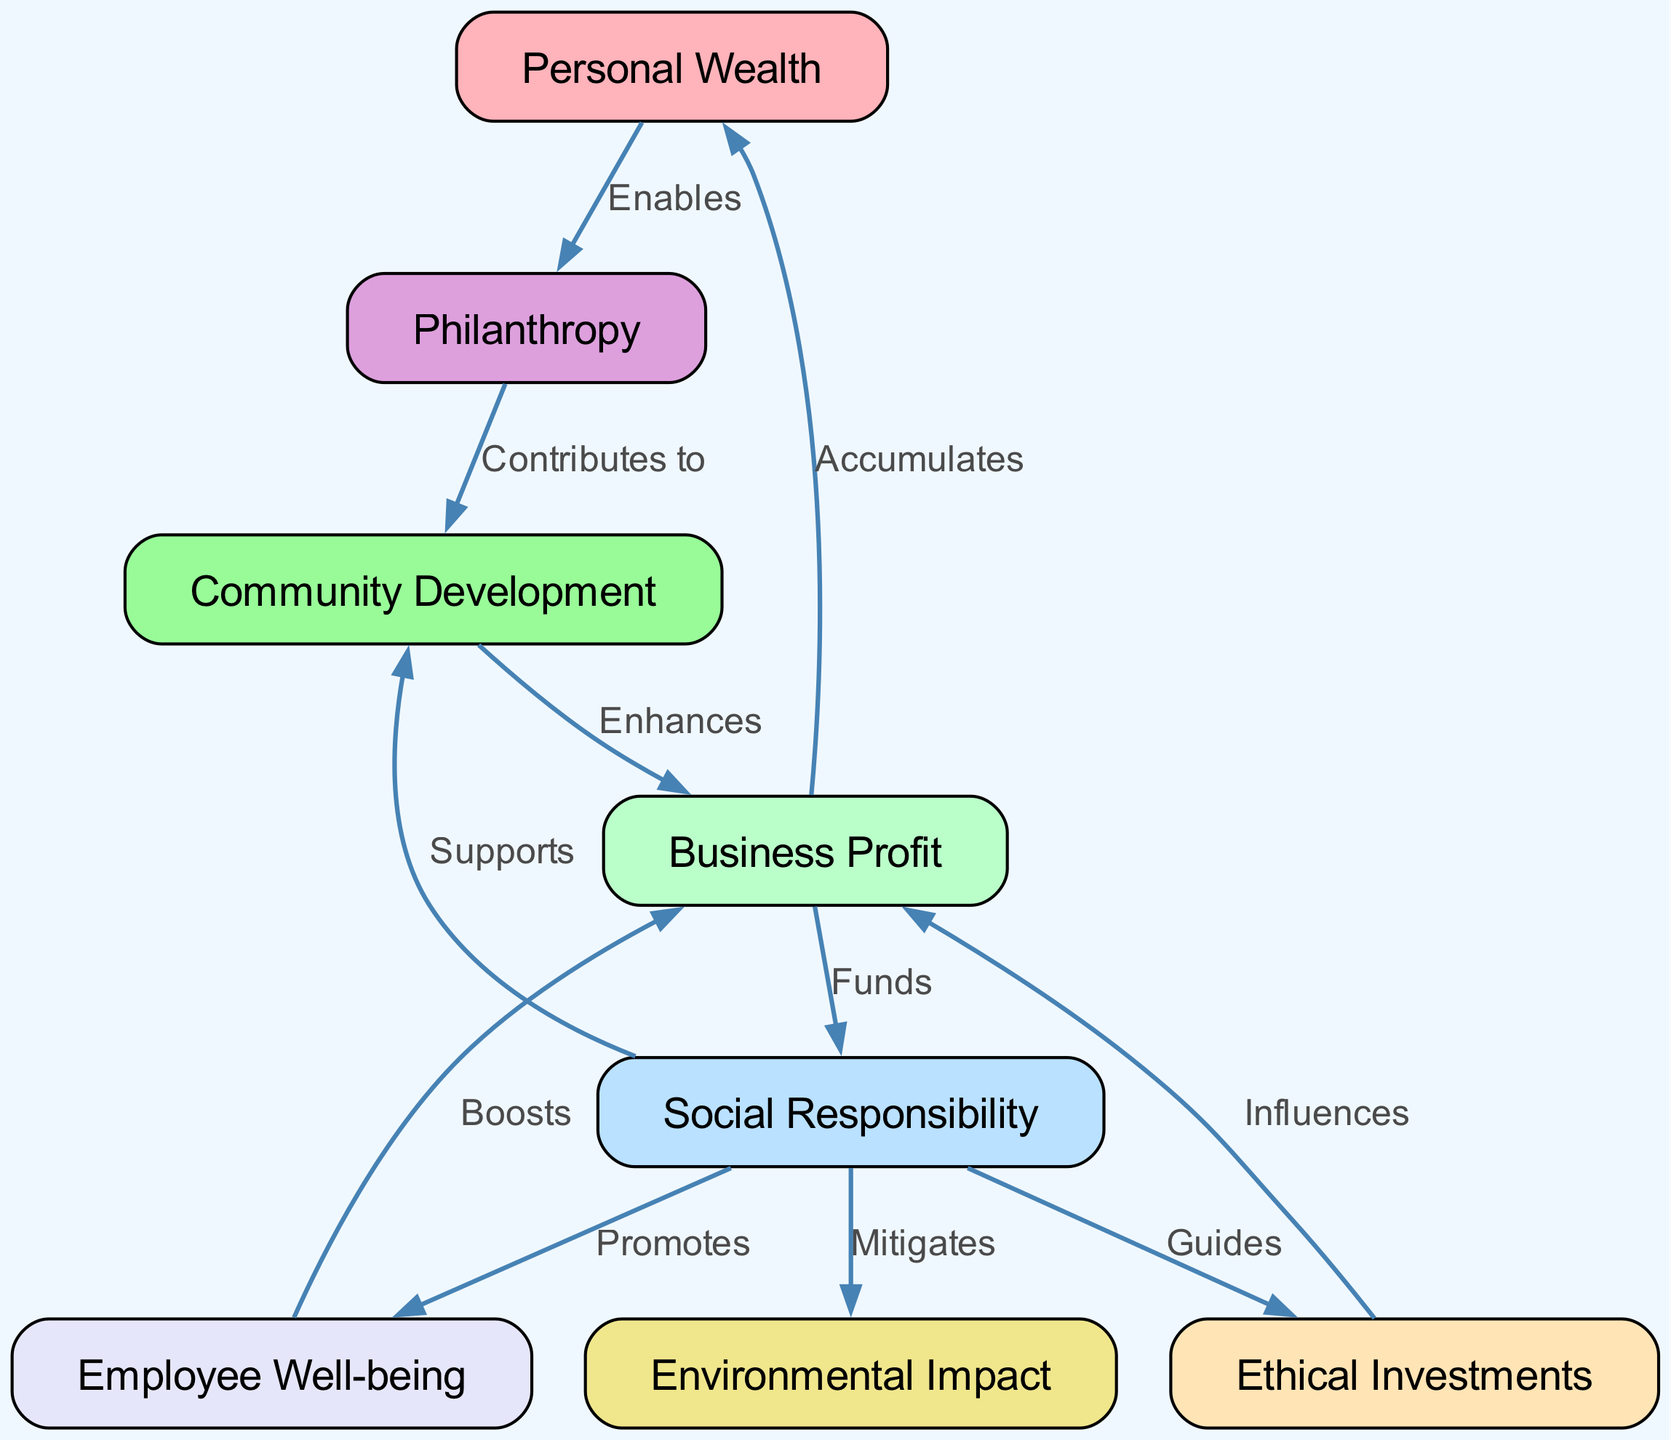What are the total number of nodes in the diagram? The diagram contains 8 distinct nodes as indicated in the data provided under "nodes." Each unique entity in the network, such as "Personal Wealth," "Business Profit," and others, counts as a separate node.
Answer: 8 What is the relation between "Business Profit" and "Personal Wealth"? The edge labeled "Accumulates" connects "Business Profit" to "Personal Wealth," indicating that business profit contributes to an increase in personal wealth. This is clearly stated in the edge's label within the diagram.
Answer: Accumulates How many edges are there in the diagram? By counting the entries listed under "edges," we find there are 10 relationships that connect the nodes. Each entry represents a directed connection from one node to another, showing their interactions.
Answer: 10 What does "Social Responsibility" promote? The diagram shows that "Social Responsibility" has an influence on "Employee Well-being," indicated by an edge labeled "Promotes." It highlights the role of social responsibility in enhancing employee experience.
Answer: Employee Well-being Which node directly supports "Community Development"? "Social Responsibility" directly connects to "Community Development" via the edge labeled "Supports." The label indicates that social responsibility plays a supportive role in community initiatives.
Answer: Social Responsibility How does "Philanthropy" relate to "Community Development"? The edge labeled "Contributes to" represents the connection between "Philanthropy" and "Community Development." This indicates that philanthropic efforts enhance or help build community development projects.
Answer: Contributes to What influences "Business Profit"? There are two nodes that influence "Business Profit": "Ethical Investments" and "Employee Well-being." The edges labeled "Influences" and "Boosts" illustrate these supporting relationships, showing how these factors can affect profitability.
Answer: Ethical Investments, Employee Well-being What connection exists between "Social Responsibility" and "Environmental Impact"? "Social Responsibility" is connected to "Environmental Impact" through the edge labeled "Mitigates." This label signifies that social responsibility efforts aim to reduce or alleviate negative environmental consequences.
Answer: Mitigates Which node is enabled by "Personal Wealth"? The diagram connects "Personal Wealth" to "Philanthropy," indicated by the edge labeled "Enables." This shows that having personal wealth allows one to engage in philanthropic activities.
Answer: Philanthropy 